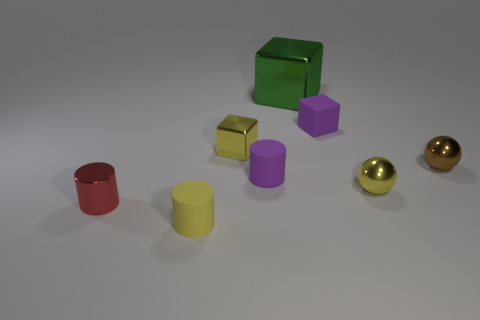What is the material of the cylinder that is the same color as the small metallic block?
Offer a very short reply. Rubber. The tiny purple object to the right of the tiny cylinder that is to the right of the tiny yellow cylinder is what shape?
Offer a terse response. Cube. Is there another small thing of the same shape as the small red thing?
Your answer should be very brief. Yes. What number of small yellow things are there?
Ensure brevity in your answer.  3. Do the cylinder that is behind the tiny red metal thing and the red thing have the same material?
Offer a very short reply. No. Are there any yellow metal objects that have the same size as the brown metal sphere?
Your answer should be very brief. Yes. Does the brown shiny thing have the same shape as the tiny yellow shiny thing that is in front of the brown metal thing?
Offer a terse response. Yes. Are there any big green metallic objects that are behind the small ball behind the tiny yellow metal object that is to the right of the small purple matte cylinder?
Provide a succinct answer. Yes. What size is the purple cube?
Offer a terse response. Small. How many other things are the same color as the metal cylinder?
Offer a terse response. 0. 